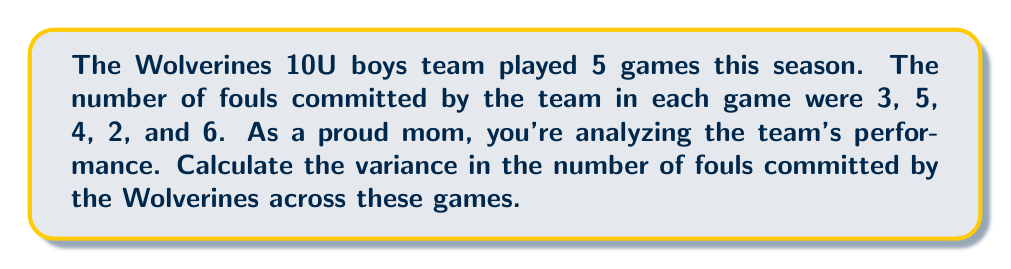Provide a solution to this math problem. Let's calculate the variance step-by-step:

1. First, we need to calculate the mean (average) number of fouls:
   $$ \mu = \frac{3 + 5 + 4 + 2 + 6}{5} = \frac{20}{5} = 4 $$

2. Now, we subtract this mean from each value and square the result:
   $$(3 - 4)^2 = (-1)^2 = 1$$
   $$(5 - 4)^2 = (1)^2 = 1$$
   $$(4 - 4)^2 = (0)^2 = 0$$
   $$(2 - 4)^2 = (-2)^2 = 4$$
   $$(6 - 4)^2 = (2)^2 = 4$$

3. We sum these squared differences:
   $$ 1 + 1 + 0 + 4 + 4 = 10 $$

4. Finally, we divide by the number of games (5) to get the variance:
   $$ \text{Variance} = \frac{10}{5} = 2 $$

Therefore, the variance in the number of fouls committed by the Wolverines is 2.
Answer: 2 